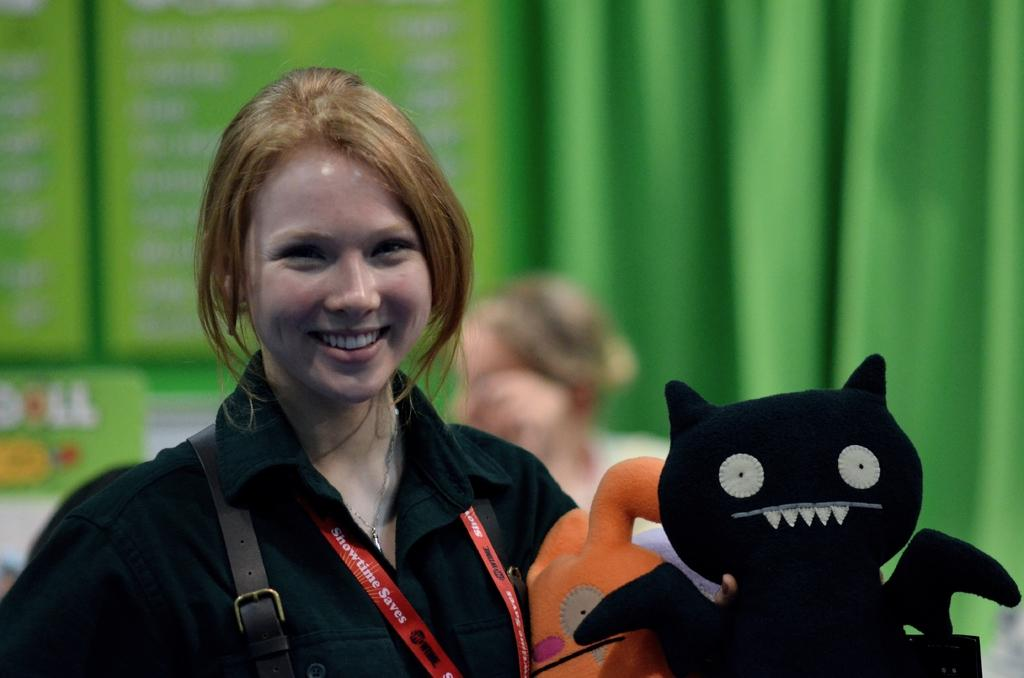Who is present in the image? There is a woman in the image. What is the woman's expression? The woman is smiling. What is the woman wearing? The woman is wearing a black shirt. What is the woman holding in the image? The woman is holding an object. What can be seen in the background of the image? There is a green curtain and a person in the background of the image. Can you tell me how many pickles the woman is holding in the image? There is no pickle present in the image; the woman is holding an object, but it is not specified as a pickle. Is there a dog visible in the image? No, there is no dog present in the image. 